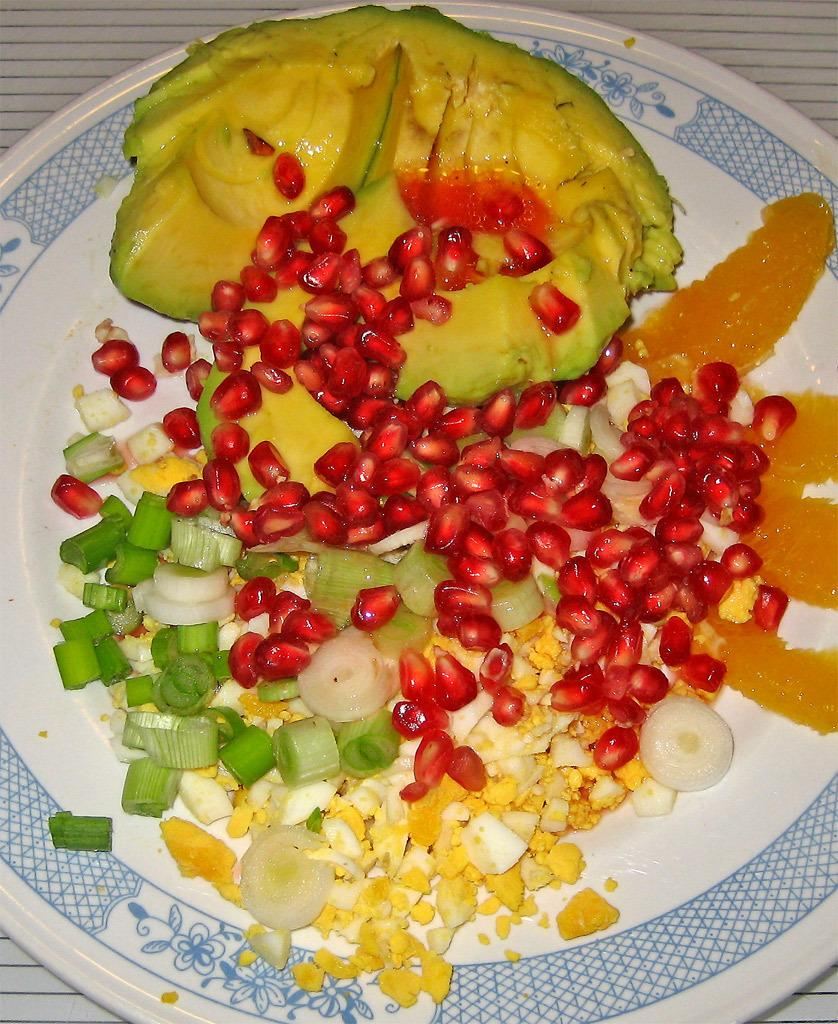What is on the plate that is visible in the image? There are pomegranates, herbs, and onions on the plate. Where is the plate located in the image? The plate is kept on the floor. How does the plate curve around the ghost in the image? There is no ghost present in the image, and the plate is not curved. 